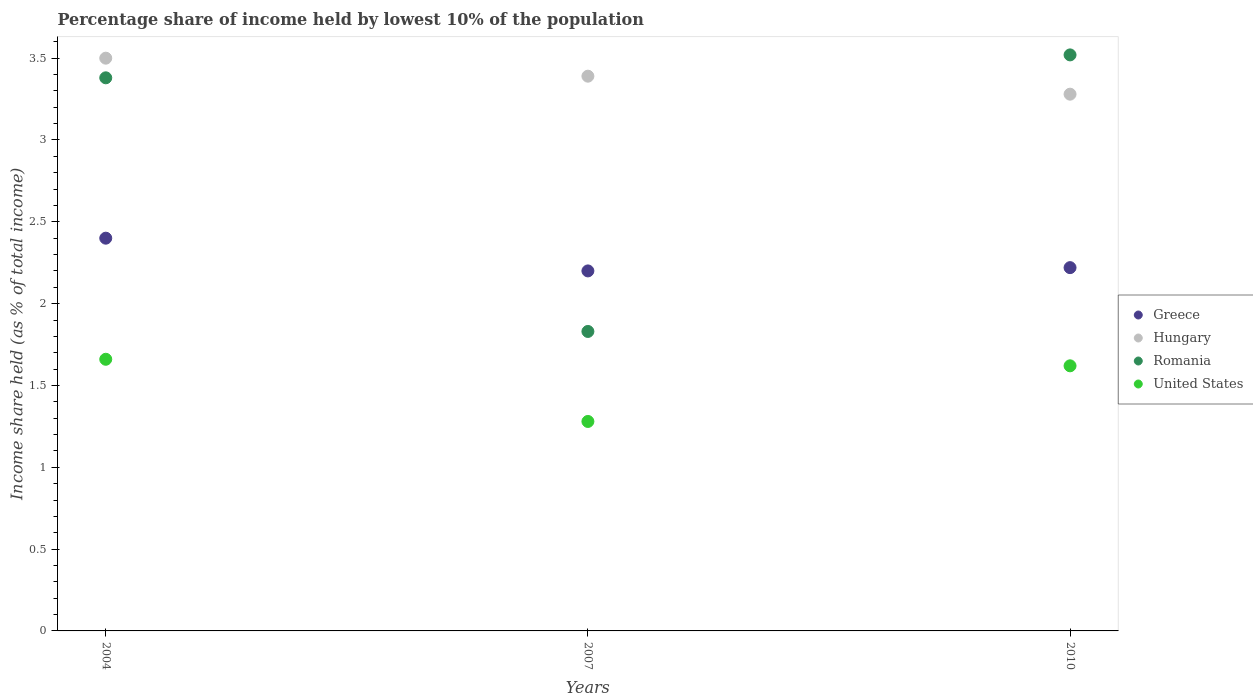Is the number of dotlines equal to the number of legend labels?
Ensure brevity in your answer.  Yes. What is the percentage share of income held by lowest 10% of the population in United States in 2010?
Offer a terse response. 1.62. Across all years, what is the maximum percentage share of income held by lowest 10% of the population in Romania?
Keep it short and to the point. 3.52. Across all years, what is the minimum percentage share of income held by lowest 10% of the population in Hungary?
Provide a succinct answer. 3.28. In which year was the percentage share of income held by lowest 10% of the population in Hungary maximum?
Provide a short and direct response. 2004. What is the total percentage share of income held by lowest 10% of the population in Hungary in the graph?
Make the answer very short. 10.17. What is the difference between the percentage share of income held by lowest 10% of the population in United States in 2004 and that in 2007?
Provide a short and direct response. 0.38. What is the difference between the percentage share of income held by lowest 10% of the population in Greece in 2004 and the percentage share of income held by lowest 10% of the population in United States in 2010?
Keep it short and to the point. 0.78. What is the average percentage share of income held by lowest 10% of the population in United States per year?
Make the answer very short. 1.52. In the year 2004, what is the difference between the percentage share of income held by lowest 10% of the population in Hungary and percentage share of income held by lowest 10% of the population in United States?
Ensure brevity in your answer.  1.84. What is the ratio of the percentage share of income held by lowest 10% of the population in Romania in 2007 to that in 2010?
Offer a very short reply. 0.52. Is the difference between the percentage share of income held by lowest 10% of the population in Hungary in 2004 and 2010 greater than the difference between the percentage share of income held by lowest 10% of the population in United States in 2004 and 2010?
Offer a terse response. Yes. What is the difference between the highest and the second highest percentage share of income held by lowest 10% of the population in Hungary?
Provide a succinct answer. 0.11. What is the difference between the highest and the lowest percentage share of income held by lowest 10% of the population in Romania?
Provide a short and direct response. 1.69. In how many years, is the percentage share of income held by lowest 10% of the population in United States greater than the average percentage share of income held by lowest 10% of the population in United States taken over all years?
Your response must be concise. 2. Is the sum of the percentage share of income held by lowest 10% of the population in Greece in 2004 and 2010 greater than the maximum percentage share of income held by lowest 10% of the population in United States across all years?
Your answer should be compact. Yes. Is it the case that in every year, the sum of the percentage share of income held by lowest 10% of the population in United States and percentage share of income held by lowest 10% of the population in Greece  is greater than the sum of percentage share of income held by lowest 10% of the population in Romania and percentage share of income held by lowest 10% of the population in Hungary?
Your answer should be very brief. Yes. Does the percentage share of income held by lowest 10% of the population in Hungary monotonically increase over the years?
Offer a terse response. No. How many dotlines are there?
Offer a very short reply. 4. How many years are there in the graph?
Your answer should be very brief. 3. Does the graph contain any zero values?
Ensure brevity in your answer.  No. How many legend labels are there?
Your answer should be very brief. 4. How are the legend labels stacked?
Your answer should be very brief. Vertical. What is the title of the graph?
Offer a terse response. Percentage share of income held by lowest 10% of the population. What is the label or title of the X-axis?
Provide a short and direct response. Years. What is the label or title of the Y-axis?
Keep it short and to the point. Income share held (as % of total income). What is the Income share held (as % of total income) in Greece in 2004?
Make the answer very short. 2.4. What is the Income share held (as % of total income) of Hungary in 2004?
Provide a short and direct response. 3.5. What is the Income share held (as % of total income) in Romania in 2004?
Provide a succinct answer. 3.38. What is the Income share held (as % of total income) in United States in 2004?
Provide a short and direct response. 1.66. What is the Income share held (as % of total income) of Greece in 2007?
Your answer should be compact. 2.2. What is the Income share held (as % of total income) in Hungary in 2007?
Keep it short and to the point. 3.39. What is the Income share held (as % of total income) of Romania in 2007?
Offer a terse response. 1.83. What is the Income share held (as % of total income) of United States in 2007?
Provide a short and direct response. 1.28. What is the Income share held (as % of total income) in Greece in 2010?
Make the answer very short. 2.22. What is the Income share held (as % of total income) of Hungary in 2010?
Your answer should be compact. 3.28. What is the Income share held (as % of total income) in Romania in 2010?
Offer a terse response. 3.52. What is the Income share held (as % of total income) in United States in 2010?
Keep it short and to the point. 1.62. Across all years, what is the maximum Income share held (as % of total income) in Romania?
Your response must be concise. 3.52. Across all years, what is the maximum Income share held (as % of total income) in United States?
Provide a short and direct response. 1.66. Across all years, what is the minimum Income share held (as % of total income) of Hungary?
Keep it short and to the point. 3.28. Across all years, what is the minimum Income share held (as % of total income) in Romania?
Your response must be concise. 1.83. Across all years, what is the minimum Income share held (as % of total income) of United States?
Keep it short and to the point. 1.28. What is the total Income share held (as % of total income) in Greece in the graph?
Offer a terse response. 6.82. What is the total Income share held (as % of total income) in Hungary in the graph?
Make the answer very short. 10.17. What is the total Income share held (as % of total income) in Romania in the graph?
Provide a succinct answer. 8.73. What is the total Income share held (as % of total income) of United States in the graph?
Give a very brief answer. 4.56. What is the difference between the Income share held (as % of total income) of Greece in 2004 and that in 2007?
Give a very brief answer. 0.2. What is the difference between the Income share held (as % of total income) in Hungary in 2004 and that in 2007?
Your answer should be compact. 0.11. What is the difference between the Income share held (as % of total income) of Romania in 2004 and that in 2007?
Offer a very short reply. 1.55. What is the difference between the Income share held (as % of total income) of United States in 2004 and that in 2007?
Make the answer very short. 0.38. What is the difference between the Income share held (as % of total income) in Greece in 2004 and that in 2010?
Your response must be concise. 0.18. What is the difference between the Income share held (as % of total income) in Hungary in 2004 and that in 2010?
Your response must be concise. 0.22. What is the difference between the Income share held (as % of total income) of Romania in 2004 and that in 2010?
Offer a very short reply. -0.14. What is the difference between the Income share held (as % of total income) in United States in 2004 and that in 2010?
Provide a succinct answer. 0.04. What is the difference between the Income share held (as % of total income) of Greece in 2007 and that in 2010?
Provide a short and direct response. -0.02. What is the difference between the Income share held (as % of total income) in Hungary in 2007 and that in 2010?
Keep it short and to the point. 0.11. What is the difference between the Income share held (as % of total income) in Romania in 2007 and that in 2010?
Ensure brevity in your answer.  -1.69. What is the difference between the Income share held (as % of total income) of United States in 2007 and that in 2010?
Ensure brevity in your answer.  -0.34. What is the difference between the Income share held (as % of total income) of Greece in 2004 and the Income share held (as % of total income) of Hungary in 2007?
Make the answer very short. -0.99. What is the difference between the Income share held (as % of total income) in Greece in 2004 and the Income share held (as % of total income) in Romania in 2007?
Give a very brief answer. 0.57. What is the difference between the Income share held (as % of total income) in Greece in 2004 and the Income share held (as % of total income) in United States in 2007?
Keep it short and to the point. 1.12. What is the difference between the Income share held (as % of total income) of Hungary in 2004 and the Income share held (as % of total income) of Romania in 2007?
Provide a short and direct response. 1.67. What is the difference between the Income share held (as % of total income) in Hungary in 2004 and the Income share held (as % of total income) in United States in 2007?
Provide a short and direct response. 2.22. What is the difference between the Income share held (as % of total income) of Romania in 2004 and the Income share held (as % of total income) of United States in 2007?
Provide a succinct answer. 2.1. What is the difference between the Income share held (as % of total income) in Greece in 2004 and the Income share held (as % of total income) in Hungary in 2010?
Make the answer very short. -0.88. What is the difference between the Income share held (as % of total income) in Greece in 2004 and the Income share held (as % of total income) in Romania in 2010?
Keep it short and to the point. -1.12. What is the difference between the Income share held (as % of total income) of Greece in 2004 and the Income share held (as % of total income) of United States in 2010?
Provide a succinct answer. 0.78. What is the difference between the Income share held (as % of total income) in Hungary in 2004 and the Income share held (as % of total income) in Romania in 2010?
Your response must be concise. -0.02. What is the difference between the Income share held (as % of total income) in Hungary in 2004 and the Income share held (as % of total income) in United States in 2010?
Give a very brief answer. 1.88. What is the difference between the Income share held (as % of total income) in Romania in 2004 and the Income share held (as % of total income) in United States in 2010?
Your answer should be very brief. 1.76. What is the difference between the Income share held (as % of total income) in Greece in 2007 and the Income share held (as % of total income) in Hungary in 2010?
Provide a succinct answer. -1.08. What is the difference between the Income share held (as % of total income) in Greece in 2007 and the Income share held (as % of total income) in Romania in 2010?
Give a very brief answer. -1.32. What is the difference between the Income share held (as % of total income) of Greece in 2007 and the Income share held (as % of total income) of United States in 2010?
Your answer should be very brief. 0.58. What is the difference between the Income share held (as % of total income) of Hungary in 2007 and the Income share held (as % of total income) of Romania in 2010?
Keep it short and to the point. -0.13. What is the difference between the Income share held (as % of total income) of Hungary in 2007 and the Income share held (as % of total income) of United States in 2010?
Ensure brevity in your answer.  1.77. What is the difference between the Income share held (as % of total income) in Romania in 2007 and the Income share held (as % of total income) in United States in 2010?
Offer a very short reply. 0.21. What is the average Income share held (as % of total income) in Greece per year?
Provide a short and direct response. 2.27. What is the average Income share held (as % of total income) of Hungary per year?
Provide a succinct answer. 3.39. What is the average Income share held (as % of total income) of Romania per year?
Provide a short and direct response. 2.91. What is the average Income share held (as % of total income) of United States per year?
Your answer should be compact. 1.52. In the year 2004, what is the difference between the Income share held (as % of total income) in Greece and Income share held (as % of total income) in Romania?
Offer a very short reply. -0.98. In the year 2004, what is the difference between the Income share held (as % of total income) in Greece and Income share held (as % of total income) in United States?
Ensure brevity in your answer.  0.74. In the year 2004, what is the difference between the Income share held (as % of total income) of Hungary and Income share held (as % of total income) of Romania?
Ensure brevity in your answer.  0.12. In the year 2004, what is the difference between the Income share held (as % of total income) in Hungary and Income share held (as % of total income) in United States?
Provide a succinct answer. 1.84. In the year 2004, what is the difference between the Income share held (as % of total income) of Romania and Income share held (as % of total income) of United States?
Your response must be concise. 1.72. In the year 2007, what is the difference between the Income share held (as % of total income) in Greece and Income share held (as % of total income) in Hungary?
Make the answer very short. -1.19. In the year 2007, what is the difference between the Income share held (as % of total income) of Greece and Income share held (as % of total income) of Romania?
Your response must be concise. 0.37. In the year 2007, what is the difference between the Income share held (as % of total income) in Hungary and Income share held (as % of total income) in Romania?
Provide a short and direct response. 1.56. In the year 2007, what is the difference between the Income share held (as % of total income) in Hungary and Income share held (as % of total income) in United States?
Your response must be concise. 2.11. In the year 2007, what is the difference between the Income share held (as % of total income) in Romania and Income share held (as % of total income) in United States?
Your response must be concise. 0.55. In the year 2010, what is the difference between the Income share held (as % of total income) of Greece and Income share held (as % of total income) of Hungary?
Make the answer very short. -1.06. In the year 2010, what is the difference between the Income share held (as % of total income) of Greece and Income share held (as % of total income) of Romania?
Provide a succinct answer. -1.3. In the year 2010, what is the difference between the Income share held (as % of total income) in Greece and Income share held (as % of total income) in United States?
Your answer should be very brief. 0.6. In the year 2010, what is the difference between the Income share held (as % of total income) in Hungary and Income share held (as % of total income) in Romania?
Keep it short and to the point. -0.24. In the year 2010, what is the difference between the Income share held (as % of total income) in Hungary and Income share held (as % of total income) in United States?
Your answer should be compact. 1.66. In the year 2010, what is the difference between the Income share held (as % of total income) of Romania and Income share held (as % of total income) of United States?
Provide a succinct answer. 1.9. What is the ratio of the Income share held (as % of total income) of Hungary in 2004 to that in 2007?
Offer a very short reply. 1.03. What is the ratio of the Income share held (as % of total income) in Romania in 2004 to that in 2007?
Keep it short and to the point. 1.85. What is the ratio of the Income share held (as % of total income) in United States in 2004 to that in 2007?
Your answer should be very brief. 1.3. What is the ratio of the Income share held (as % of total income) in Greece in 2004 to that in 2010?
Offer a very short reply. 1.08. What is the ratio of the Income share held (as % of total income) of Hungary in 2004 to that in 2010?
Your answer should be very brief. 1.07. What is the ratio of the Income share held (as % of total income) in Romania in 2004 to that in 2010?
Provide a succinct answer. 0.96. What is the ratio of the Income share held (as % of total income) in United States in 2004 to that in 2010?
Give a very brief answer. 1.02. What is the ratio of the Income share held (as % of total income) in Hungary in 2007 to that in 2010?
Your response must be concise. 1.03. What is the ratio of the Income share held (as % of total income) in Romania in 2007 to that in 2010?
Provide a succinct answer. 0.52. What is the ratio of the Income share held (as % of total income) of United States in 2007 to that in 2010?
Your response must be concise. 0.79. What is the difference between the highest and the second highest Income share held (as % of total income) in Greece?
Make the answer very short. 0.18. What is the difference between the highest and the second highest Income share held (as % of total income) in Hungary?
Your answer should be compact. 0.11. What is the difference between the highest and the second highest Income share held (as % of total income) of Romania?
Make the answer very short. 0.14. What is the difference between the highest and the second highest Income share held (as % of total income) of United States?
Make the answer very short. 0.04. What is the difference between the highest and the lowest Income share held (as % of total income) in Greece?
Give a very brief answer. 0.2. What is the difference between the highest and the lowest Income share held (as % of total income) in Hungary?
Your answer should be compact. 0.22. What is the difference between the highest and the lowest Income share held (as % of total income) in Romania?
Offer a very short reply. 1.69. What is the difference between the highest and the lowest Income share held (as % of total income) of United States?
Offer a terse response. 0.38. 